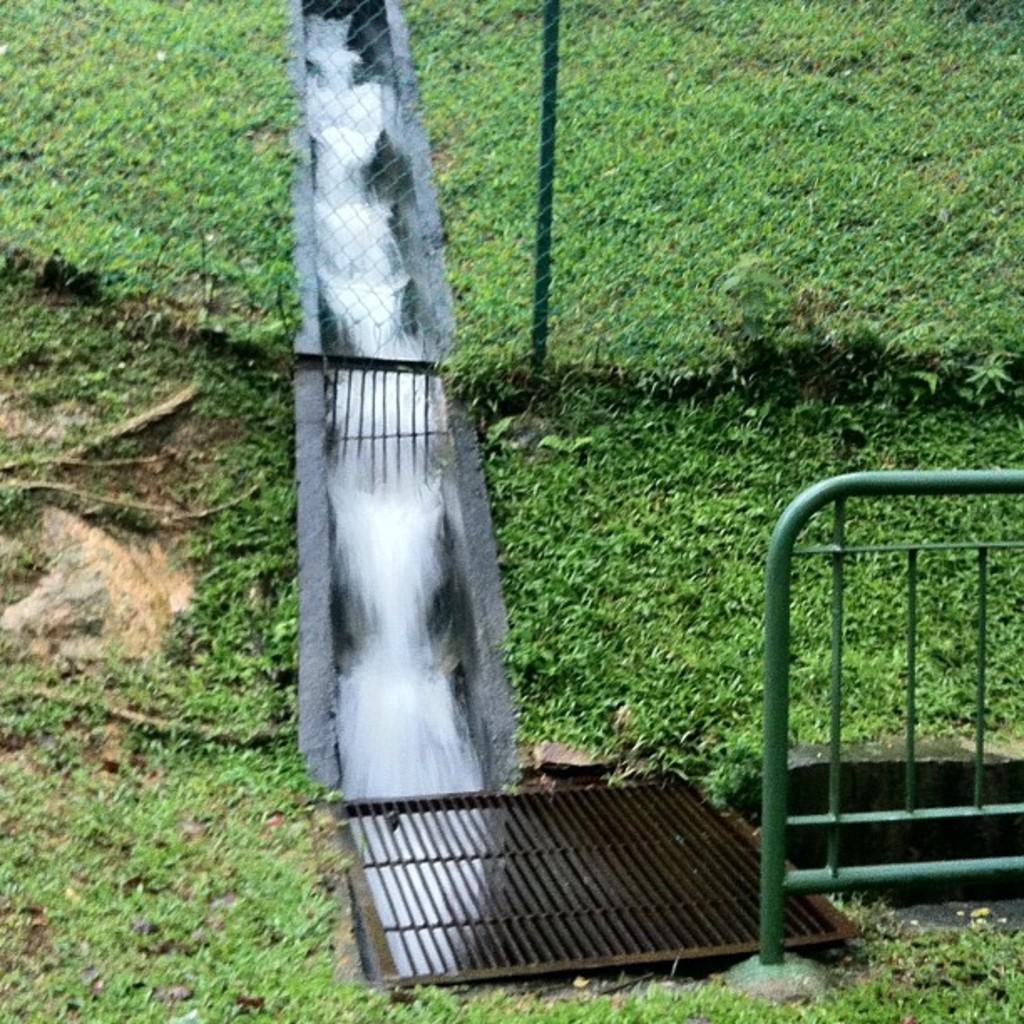In one or two sentences, can you explain what this image depicts? In this image we can see water flowing on a structure looks like a dam and there is a railing, a grille and grass. 